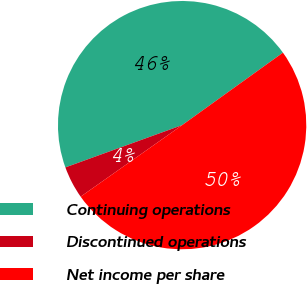Convert chart. <chart><loc_0><loc_0><loc_500><loc_500><pie_chart><fcel>Continuing operations<fcel>Discontinued operations<fcel>Net income per share<nl><fcel>45.61%<fcel>4.24%<fcel>50.15%<nl></chart> 